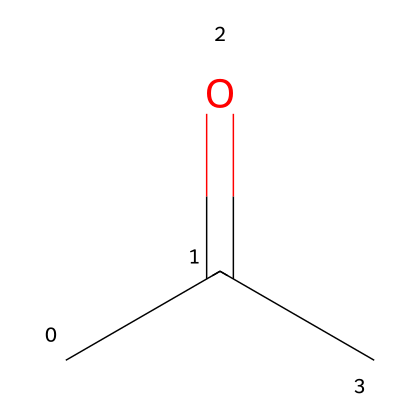How many carbon atoms are in acetone? The SMILES representation shows "CC(=O)C", indicating that there are three 'C' characters, which correspond to three carbon atoms in the molecule.
Answer: 3 What type of functional group is present in acetone? The presence of the carbonyl group (C=O), which is characteristic of ketones, means that acetone has a ketone functional group.
Answer: ketone What is the total number of hydrogen atoms in acetone? From the SMILES, there are three carbon atoms and the structure indicates that there are six hydrogen atoms bound to them, calculated as per the valency of carbon and hydrogen arrangements in the presence of a carbonyl group.
Answer: 6 What is the molecular formula of acetone? By combining the counts of carbon, hydrogen, and oxygen from the SMILES representation, we can deduce the molecular formula: C3H6O, where C is for carbon, H for hydrogen, and O for oxygen.
Answer: C3H6O Which atom is the central atom in the ketone structure of acetone? In acetone, the central carbon atom is bonded to the carbonyl oxygen and the two other carbon atoms, representing the structure of ketones where the carbonyl group is flanked by two carbon atoms.
Answer: carbon 